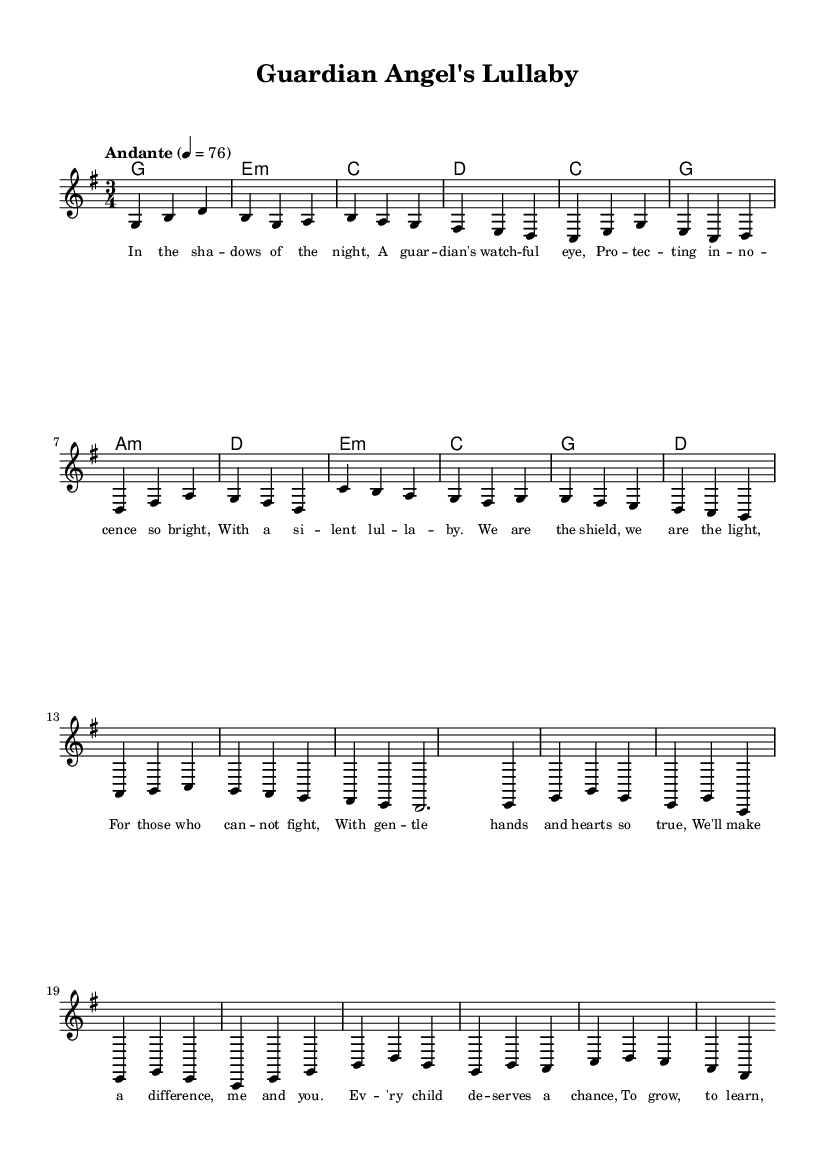What is the key signature of this music? The key signature shows one sharp, which corresponds to the key of G major.
Answer: G major What is the time signature of this piece? The time signature is indicated at the beginning of the score, showing a 3/4 pattern, which means there are three beats per measure.
Answer: 3/4 What is the tempo marking for this piece? The tempo is marked as "Andante" with a metronome marking of 76 beats per minute, indicating a moderately slow pace.
Answer: Andante, 76 What are the main themes present in the lyrics? The lyrics focus on themes of protection, guardianship, and making a positive difference in the lives of children.
Answer: Protection, guardianship How many lines compose the chorus in the lyrics? The chorus consists of six lines, as counted from the provided lyrics section.
Answer: 6 lines What is the primary purpose of this ballad? The primary purpose of the ballad is to evoke a sense of comfort and assurance, portraying a protective role toward children.
Answer: To provide comfort and assurance Which section of the song emphasizes the idea of making a difference? The chorus explicitly emphasizes making a difference by stating that "We'll make a difference, me and you."
Answer: The chorus 